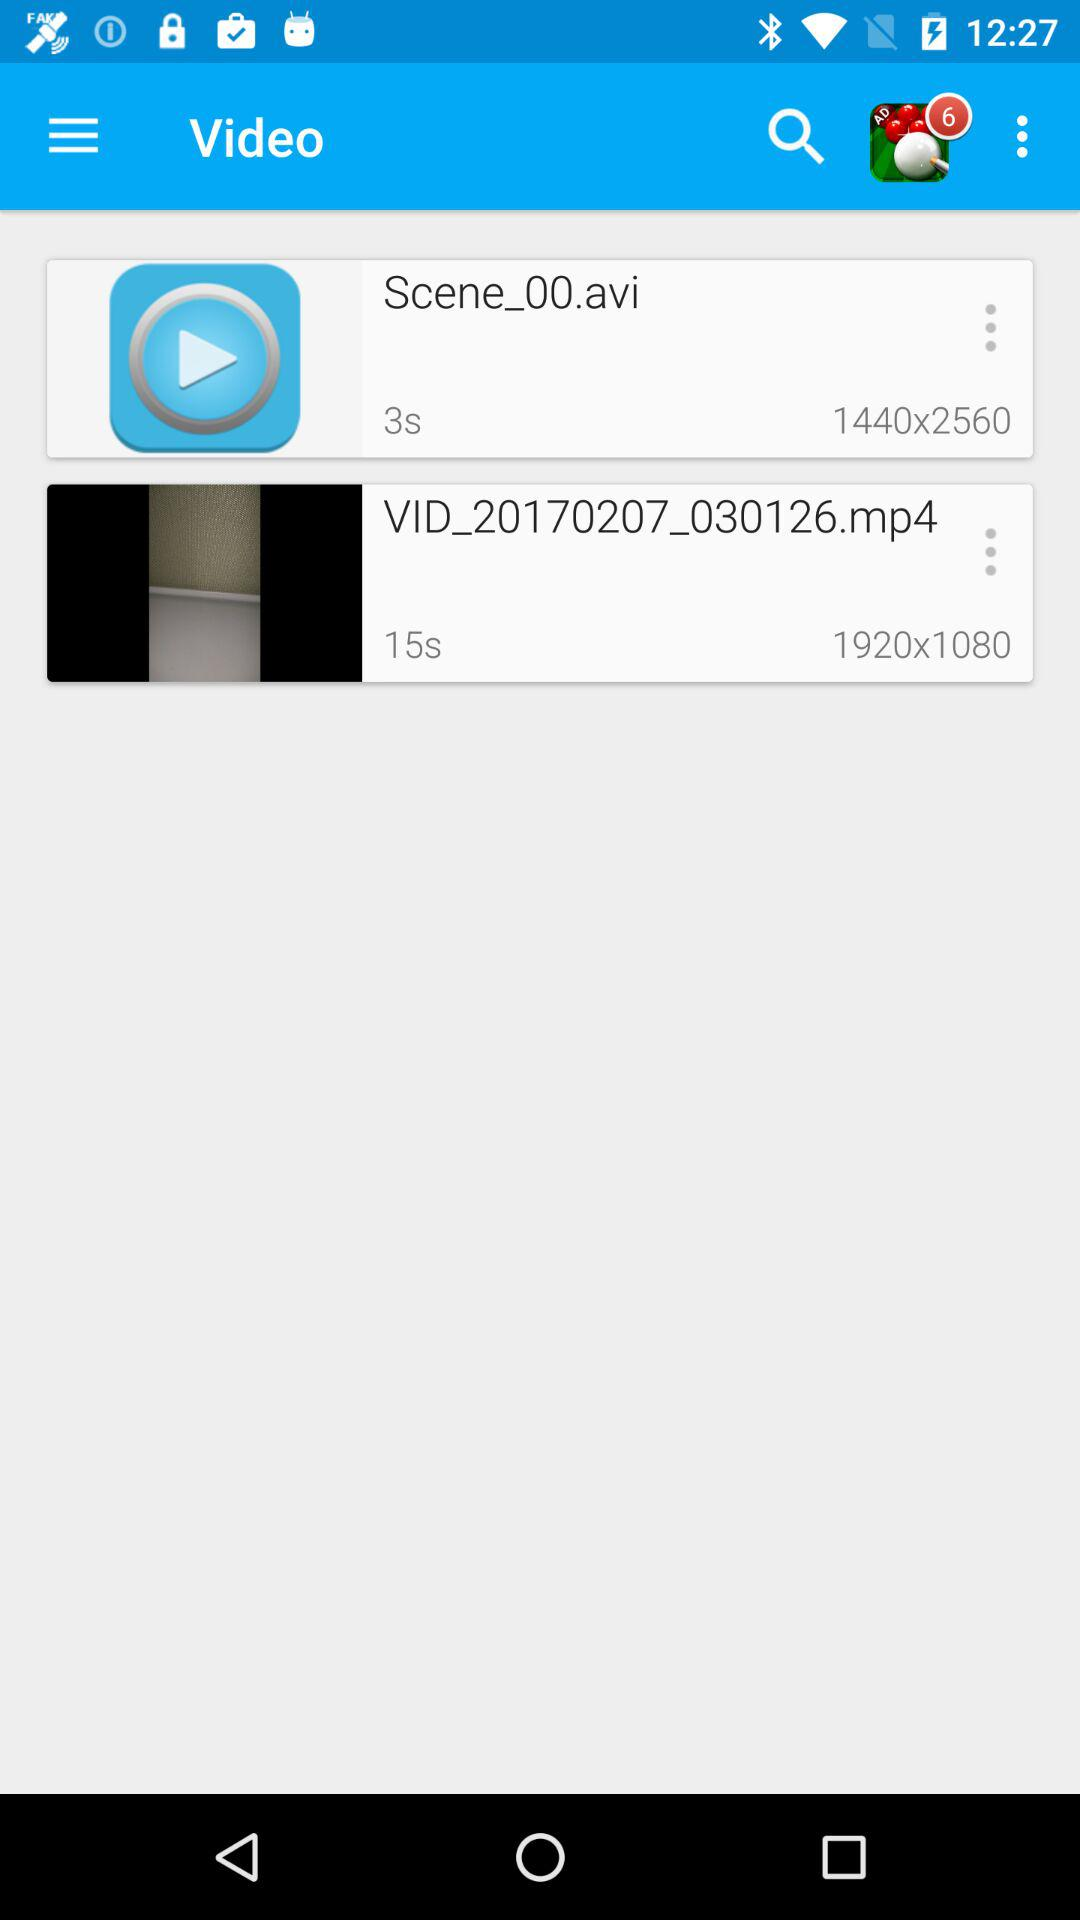How many seconds longer is the second video than the first?
Answer the question using a single word or phrase. 12 